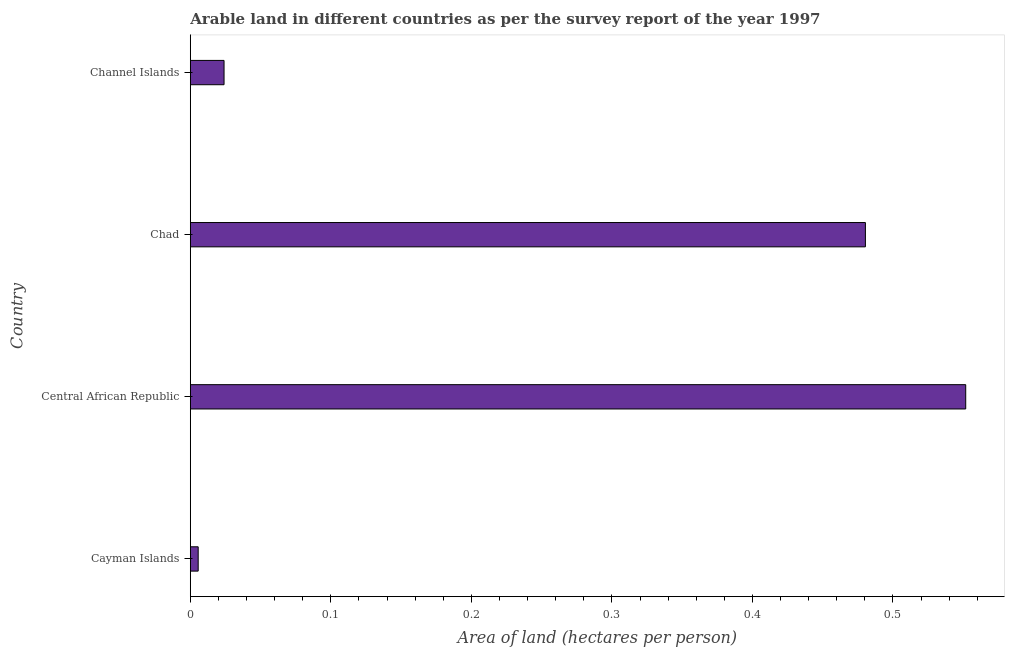Does the graph contain grids?
Ensure brevity in your answer.  No. What is the title of the graph?
Offer a very short reply. Arable land in different countries as per the survey report of the year 1997. What is the label or title of the X-axis?
Offer a very short reply. Area of land (hectares per person). What is the label or title of the Y-axis?
Your answer should be very brief. Country. What is the area of arable land in Cayman Islands?
Ensure brevity in your answer.  0.01. Across all countries, what is the maximum area of arable land?
Give a very brief answer. 0.55. Across all countries, what is the minimum area of arable land?
Give a very brief answer. 0.01. In which country was the area of arable land maximum?
Your answer should be very brief. Central African Republic. In which country was the area of arable land minimum?
Offer a very short reply. Cayman Islands. What is the sum of the area of arable land?
Ensure brevity in your answer.  1.06. What is the difference between the area of arable land in Central African Republic and Chad?
Give a very brief answer. 0.07. What is the average area of arable land per country?
Your answer should be compact. 0.27. What is the median area of arable land?
Ensure brevity in your answer.  0.25. What is the ratio of the area of arable land in Central African Republic to that in Channel Islands?
Offer a very short reply. 22.97. What is the difference between the highest and the second highest area of arable land?
Provide a succinct answer. 0.07. What is the difference between the highest and the lowest area of arable land?
Ensure brevity in your answer.  0.55. In how many countries, is the area of arable land greater than the average area of arable land taken over all countries?
Provide a short and direct response. 2. How many bars are there?
Your answer should be very brief. 4. Are all the bars in the graph horizontal?
Give a very brief answer. Yes. How many countries are there in the graph?
Offer a very short reply. 4. What is the difference between two consecutive major ticks on the X-axis?
Your answer should be very brief. 0.1. Are the values on the major ticks of X-axis written in scientific E-notation?
Ensure brevity in your answer.  No. What is the Area of land (hectares per person) in Cayman Islands?
Keep it short and to the point. 0.01. What is the Area of land (hectares per person) in Central African Republic?
Provide a short and direct response. 0.55. What is the Area of land (hectares per person) in Chad?
Your answer should be compact. 0.48. What is the Area of land (hectares per person) in Channel Islands?
Make the answer very short. 0.02. What is the difference between the Area of land (hectares per person) in Cayman Islands and Central African Republic?
Make the answer very short. -0.55. What is the difference between the Area of land (hectares per person) in Cayman Islands and Chad?
Offer a very short reply. -0.47. What is the difference between the Area of land (hectares per person) in Cayman Islands and Channel Islands?
Keep it short and to the point. -0.02. What is the difference between the Area of land (hectares per person) in Central African Republic and Chad?
Provide a succinct answer. 0.07. What is the difference between the Area of land (hectares per person) in Central African Republic and Channel Islands?
Offer a terse response. 0.53. What is the difference between the Area of land (hectares per person) in Chad and Channel Islands?
Provide a short and direct response. 0.46. What is the ratio of the Area of land (hectares per person) in Cayman Islands to that in Chad?
Keep it short and to the point. 0.01. What is the ratio of the Area of land (hectares per person) in Cayman Islands to that in Channel Islands?
Make the answer very short. 0.23. What is the ratio of the Area of land (hectares per person) in Central African Republic to that in Chad?
Offer a terse response. 1.15. What is the ratio of the Area of land (hectares per person) in Central African Republic to that in Channel Islands?
Provide a succinct answer. 22.97. What is the ratio of the Area of land (hectares per person) in Chad to that in Channel Islands?
Ensure brevity in your answer.  20. 